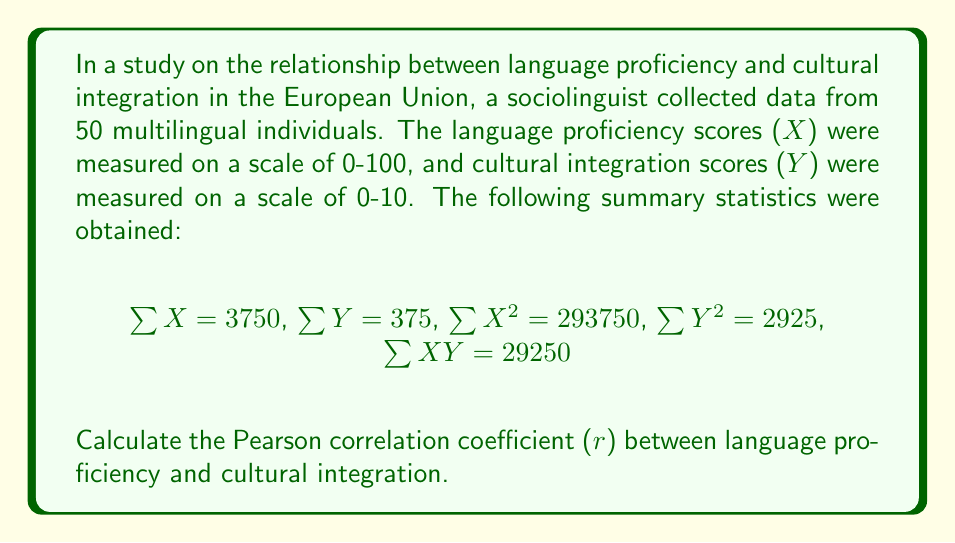Can you answer this question? To calculate the Pearson correlation coefficient (r), we'll use the formula:

$$r = \frac{n\sum XY - \sum X \sum Y}{\sqrt{[n\sum X^2 - (\sum X)^2][n\sum Y^2 - (\sum Y)^2]}}$$

Where n is the number of data points (50 in this case).

Step 1: Calculate the numerator
$$n\sum XY - \sum X \sum Y = 50(29250) - 3750(375) = 12500$$

Step 2: Calculate the first part of the denominator
$$n\sum X^2 - (\sum X)^2 = 50(293750) - 3750^2 = 187500$$

Step 3: Calculate the second part of the denominator
$$n\sum Y^2 - (\sum Y)^2 = 50(2925) - 375^2 = 3750$$

Step 4: Multiply the two parts of the denominator and take the square root
$$\sqrt{187500 \times 3750} = \sqrt{703125000} = 26515.15$$

Step 5: Divide the numerator by the denominator
$$r = \frac{12500}{26515.15} = 0.4714$$

Therefore, the Pearson correlation coefficient between language proficiency and cultural integration is approximately 0.4714.
Answer: $r \approx 0.4714$ 